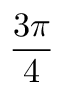<formula> <loc_0><loc_0><loc_500><loc_500>\frac { 3 \pi } { 4 }</formula> 